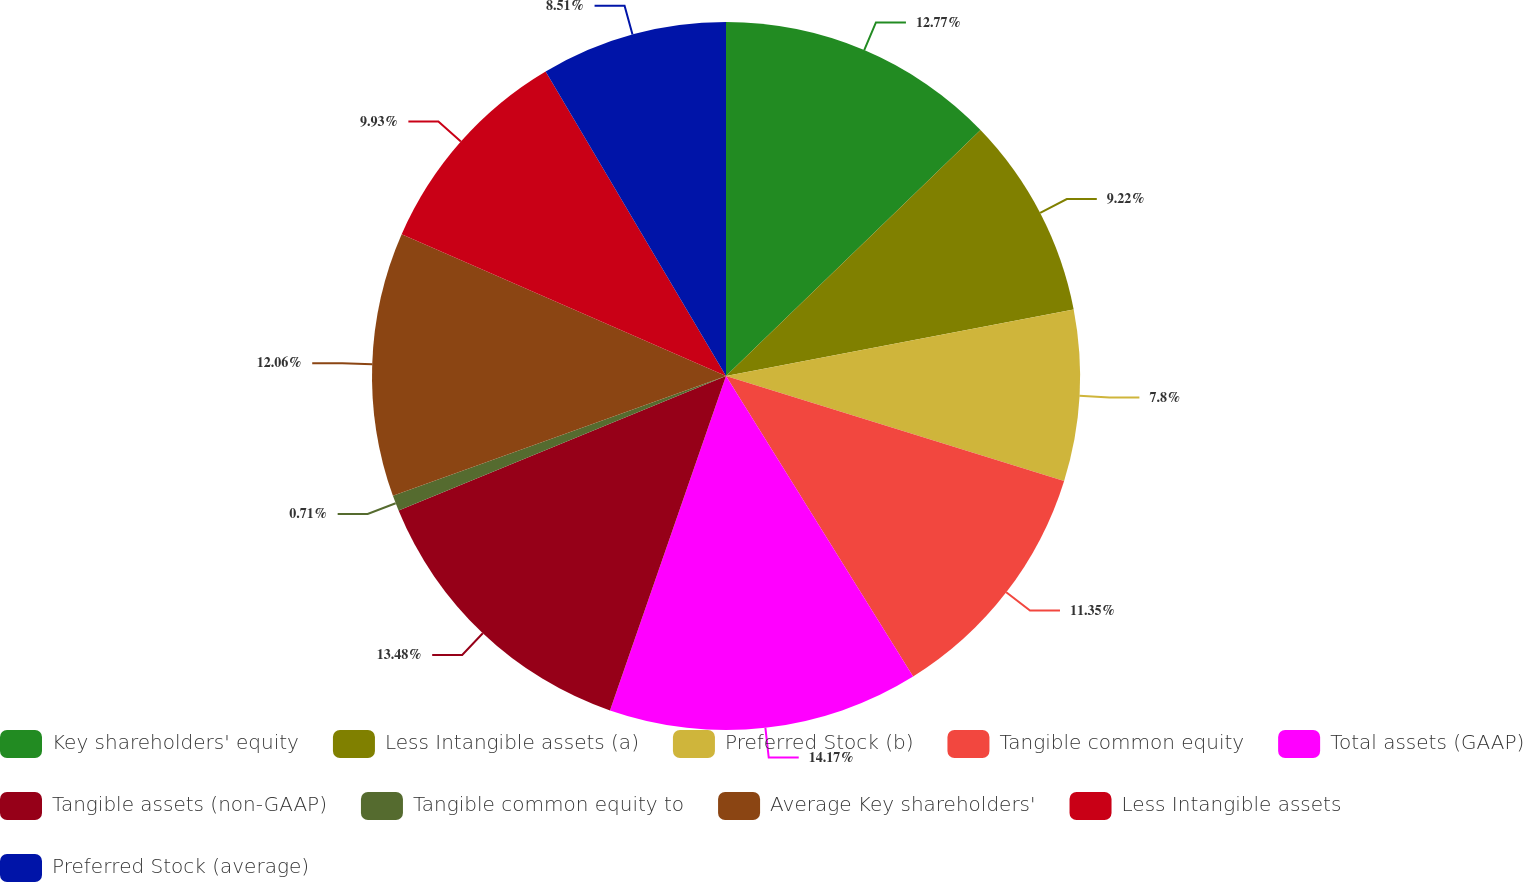Convert chart to OTSL. <chart><loc_0><loc_0><loc_500><loc_500><pie_chart><fcel>Key shareholders' equity<fcel>Less Intangible assets (a)<fcel>Preferred Stock (b)<fcel>Tangible common equity<fcel>Total assets (GAAP)<fcel>Tangible assets (non-GAAP)<fcel>Tangible common equity to<fcel>Average Key shareholders'<fcel>Less Intangible assets<fcel>Preferred Stock (average)<nl><fcel>12.77%<fcel>9.22%<fcel>7.8%<fcel>11.35%<fcel>14.18%<fcel>13.48%<fcel>0.71%<fcel>12.06%<fcel>9.93%<fcel>8.51%<nl></chart> 